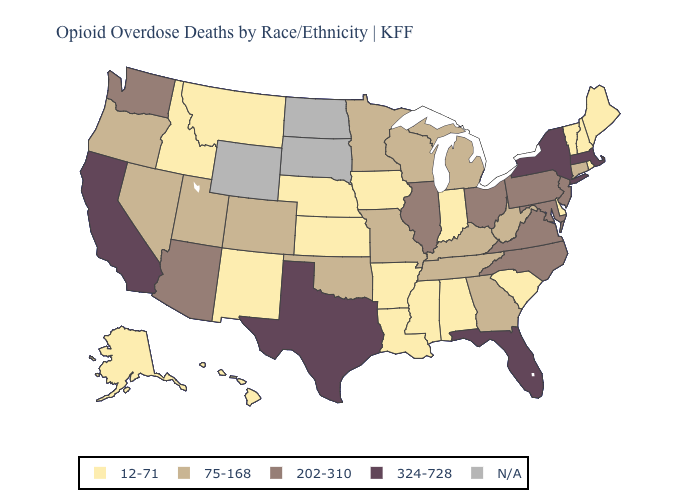What is the highest value in states that border Wisconsin?
Concise answer only. 202-310. Which states have the highest value in the USA?
Quick response, please. California, Florida, Massachusetts, New York, Texas. Among the states that border Nevada , which have the lowest value?
Be succinct. Idaho. Which states have the highest value in the USA?
Be succinct. California, Florida, Massachusetts, New York, Texas. Among the states that border New Hampshire , does Maine have the highest value?
Keep it brief. No. Is the legend a continuous bar?
Short answer required. No. Name the states that have a value in the range N/A?
Short answer required. North Dakota, South Dakota, Wyoming. What is the lowest value in the USA?
Concise answer only. 12-71. What is the highest value in the West ?
Be succinct. 324-728. What is the value of Rhode Island?
Answer briefly. 12-71. Does Texas have the highest value in the South?
Quick response, please. Yes. Does Texas have the lowest value in the USA?
Concise answer only. No. Name the states that have a value in the range 324-728?
Concise answer only. California, Florida, Massachusetts, New York, Texas. 